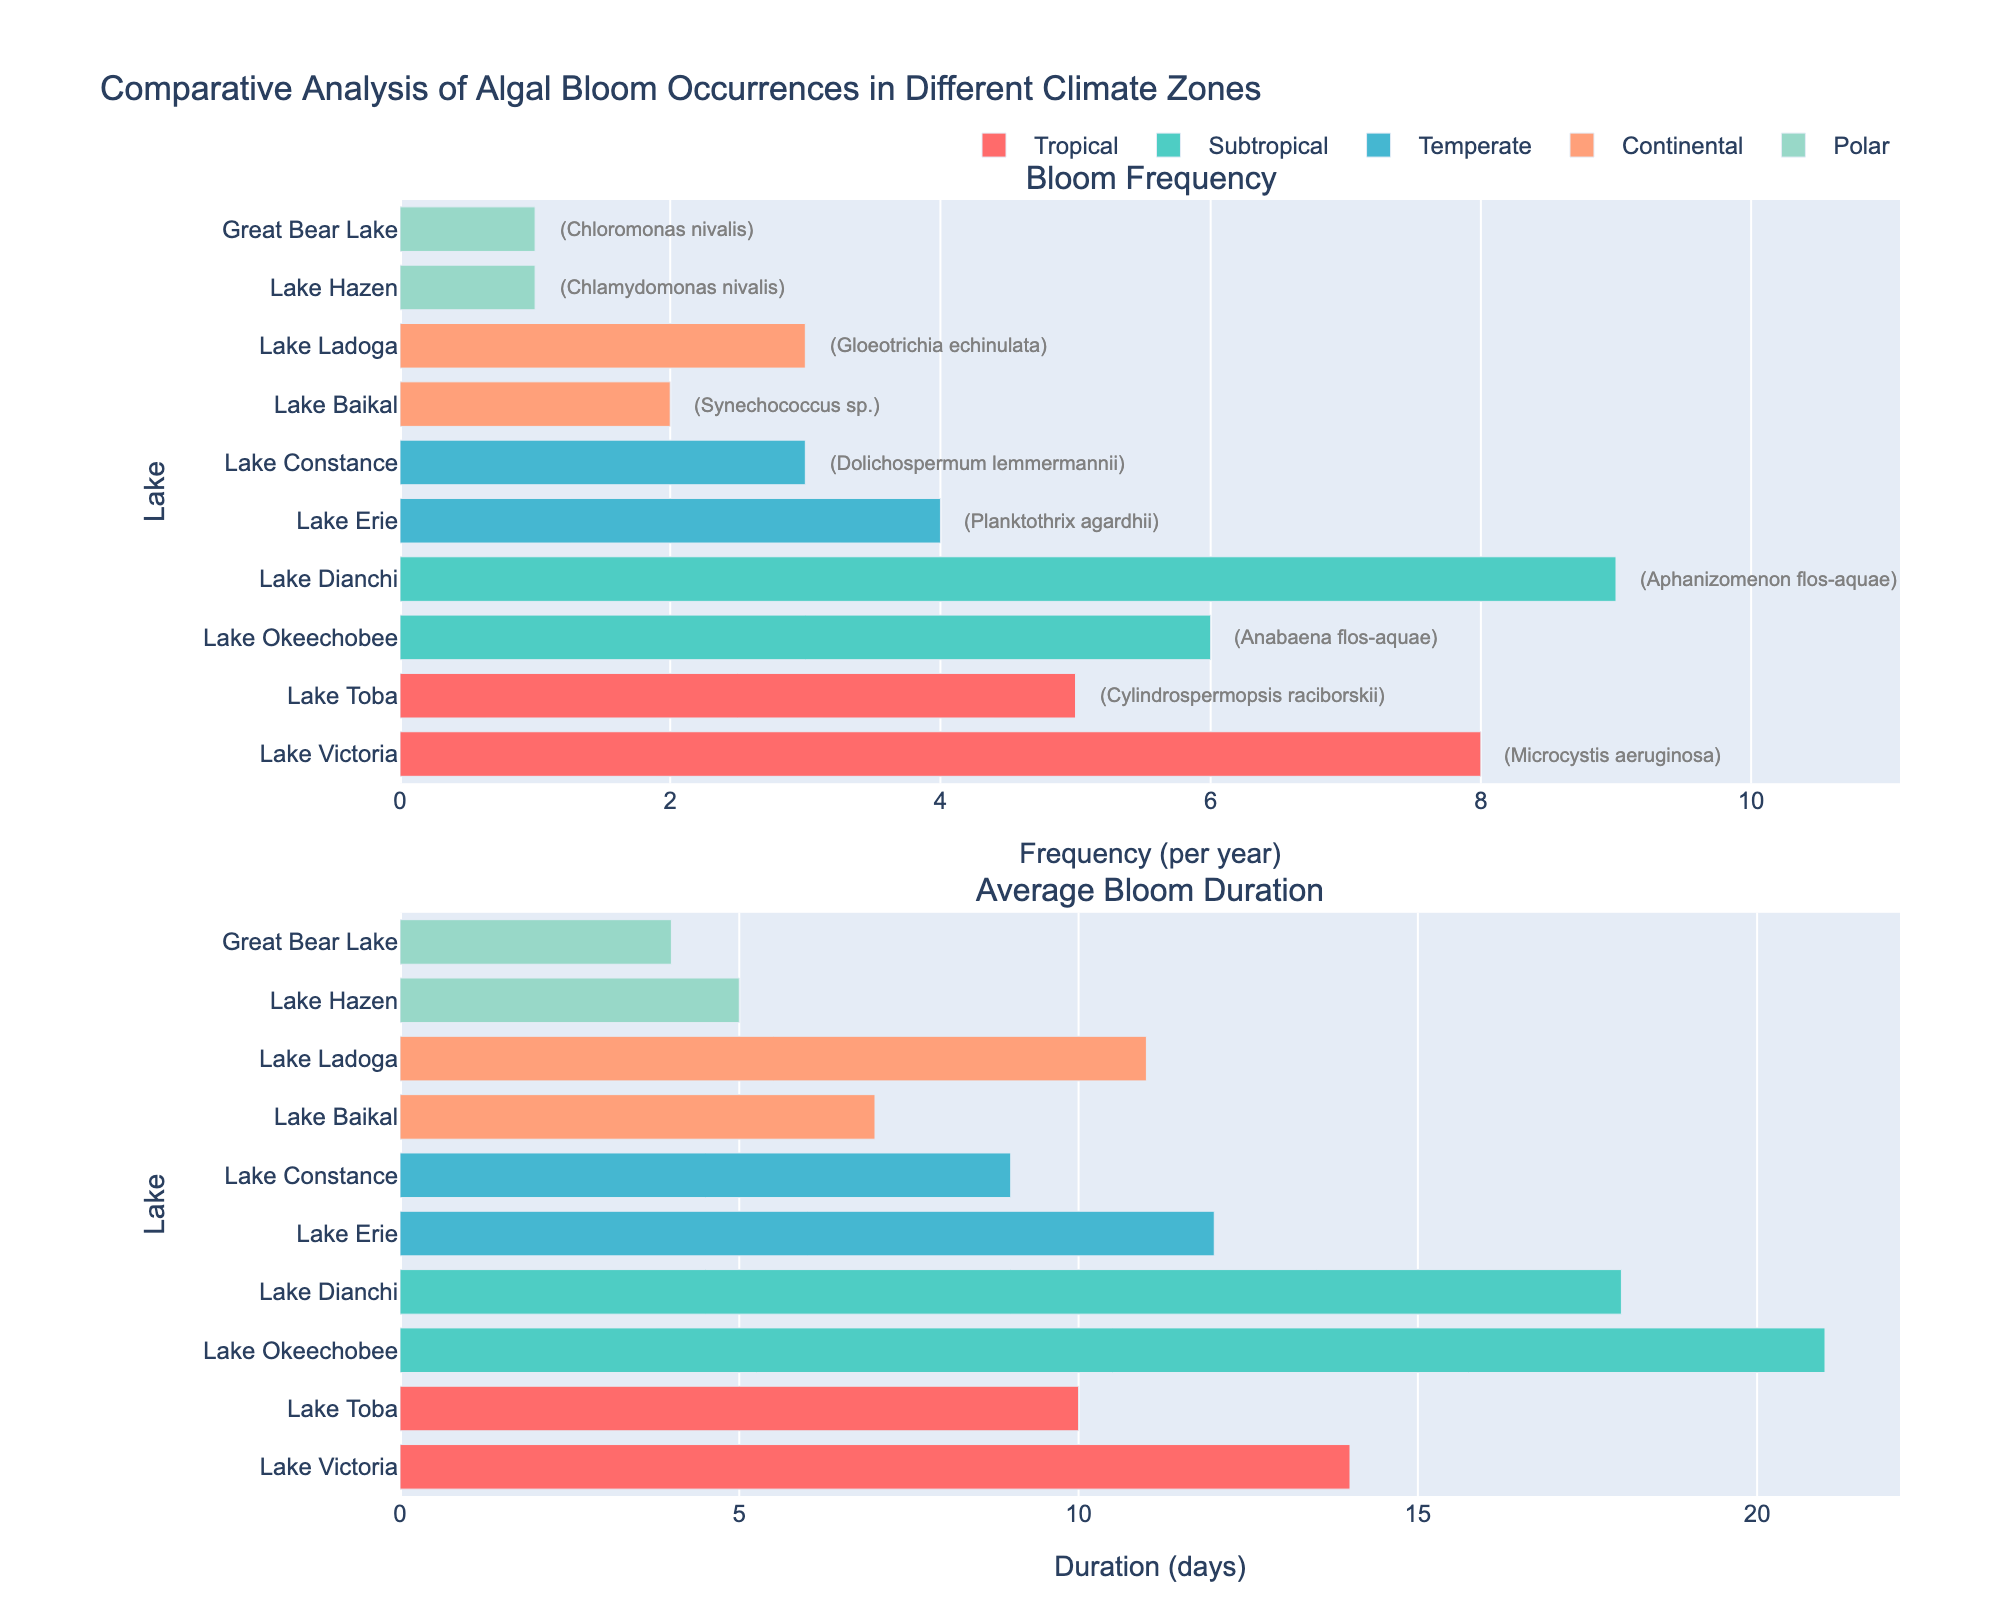What is the title of the figure? The title is usually displayed at the top of the figure. In this case, it is "Comparative Analysis of Algal Bloom Occurrences in Different Climate Zones".
Answer: Comparative Analysis of Algal Bloom Occurrences in Different Climate Zones Which lake has the highest bloom frequency in the Tropical climate zone? By looking at the first subplot showing "Bloom Frequency" for the Tropical climate zone, Lake Victoria has the highest bloom frequency.
Answer: Lake Victoria How many lakes in the Polar climate zone are shown in the figure? The figure displays bars for each lake in the "Average Bloom Duration" subplot; counting the bars labeled under the Polar climate zone, there are two lakes.
Answer: 2 What is the bloom frequency for Lake Erie? Refer to the first subplot and look for the bar labeled Lake Erie; the value on the x-axis corresponding to this bar is 4 blooms per year.
Answer: 4 Which lake has the shortest average bloom duration in the Continental climate zone? In the "Average Bloom Duration" subplot, Lake Baikal has the shortest bar among the lakes in the Continental climate zone, indicating it has the shortest average bloom duration.
Answer: Lake Baikal Compare the bloom frequency of Lake Dianchi and Lake Okeechobee. Which one is greater and by how much? From the first subplot, the bloom frequency of Lake Dianchi is 9, and Lake Okeechobee is 6. Subtracting these gives 9 - 6 = 3; hence, Lake Dianchi has a greater bloom frequency by 3.
Answer: Lake Dianchi by 3 What is the difference in average bloom duration between Lake Constance and Lake Toba? In the second subplot, the average bloom duration for Lake Constance is 9 days and for Lake Toba is 10 days. So, the difference is 10 - 9 = 1 day.
Answer: 1 day Which climate zone do the majority of lakes belong to? By counting the number of lakes corresponding to each climate zone in the subplots, the Subtropical and Temperate zones each have 2 lakes, and others have fewer. Thus, Subtropical and Temperate have the majority, but neither is larger than the other alone.
Answer: Subtropical and Temperate Which lake and climate zone combination has the smallest bloom frequency and average bloom duration? In both subplots, Lake Hazen in the Polar climate zone has the smallest bloom frequency (1) and the smallest average bloom duration (5 days) together.
Answer: Lake Hazen in the Polar zone 